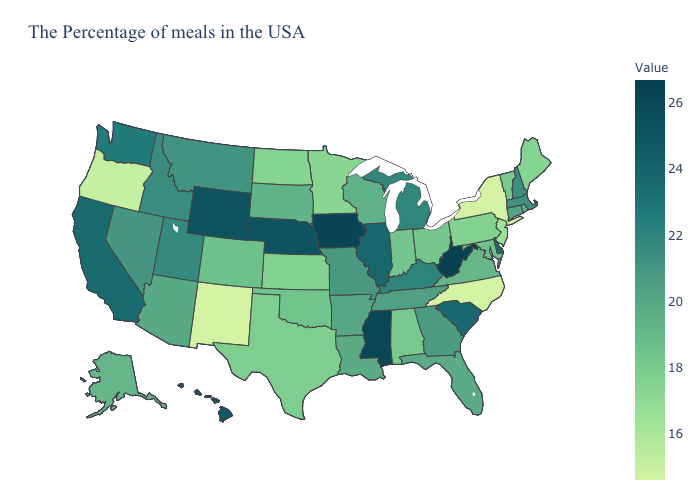Which states hav the highest value in the Northeast?
Give a very brief answer. New Hampshire. Is the legend a continuous bar?
Be succinct. Yes. Among the states that border Georgia , which have the highest value?
Be succinct. South Carolina. Does Arizona have a lower value than New Mexico?
Keep it brief. No. Which states have the lowest value in the South?
Answer briefly. North Carolina. Among the states that border Mississippi , does Alabama have the lowest value?
Keep it brief. Yes. 